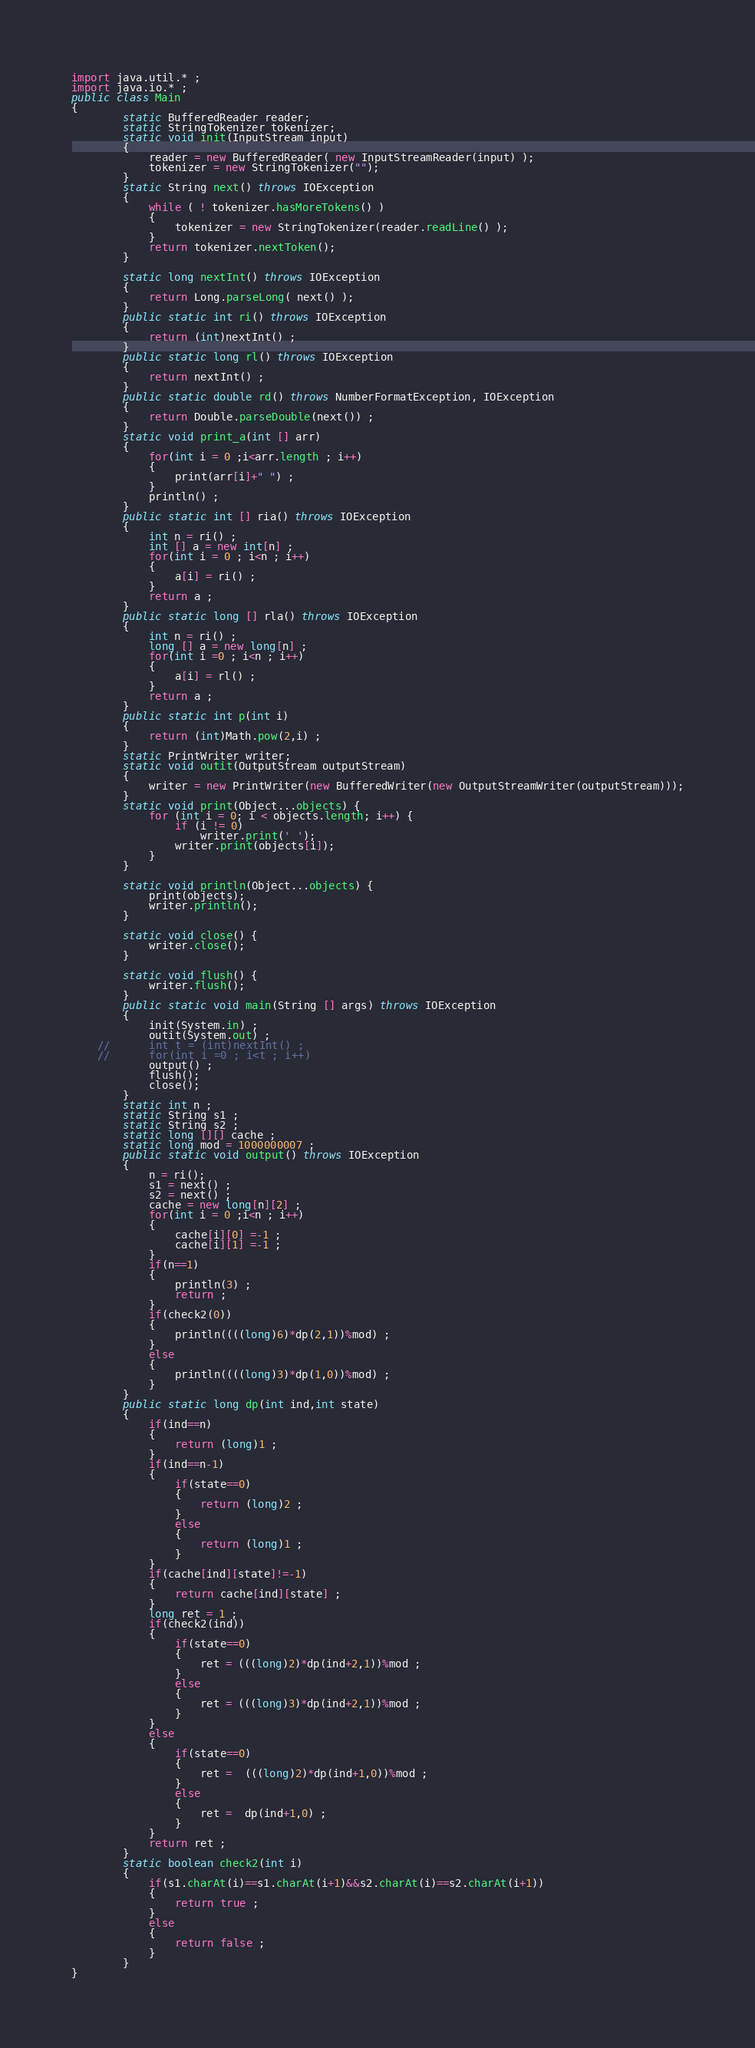<code> <loc_0><loc_0><loc_500><loc_500><_Java_>import java.util.* ;
import java.io.* ;
public class Main
{
		static BufferedReader reader;
        static StringTokenizer tokenizer;
        static void init(InputStream input)
        {
            reader = new BufferedReader( new InputStreamReader(input) );
            tokenizer = new StringTokenizer("");
        }
        static String next() throws IOException
        {
            while ( ! tokenizer.hasMoreTokens() )
            {
                tokenizer = new StringTokenizer(reader.readLine() );
            }
            return tokenizer.nextToken();
        }
     
        static long nextInt() throws IOException
        {
            return Long.parseLong( next() );
        }
        public static int ri() throws IOException
        {
        	return (int)nextInt() ;
        }
        public static long rl() throws IOException
        {
        	return nextInt() ;
        }
        public static double rd() throws NumberFormatException, IOException
        {
        	return Double.parseDouble(next()) ;
        }
        static void print_a(int [] arr)
        {
        	for(int i = 0 ;i<arr.length ; i++)
        	{
        		print(arr[i]+" ") ;
        	}
        	println() ;
        }
        public static int [] ria() throws IOException
        {
        	int n = ri() ;
        	int [] a = new int[n] ;
        	for(int i = 0 ; i<n ; i++)
        	{
        		a[i] = ri() ;
        	}
        	return a ;
        }
        public static long [] rla() throws IOException
        {
        	int n = ri() ;
        	long [] a = new long[n] ;
        	for(int i =0 ; i<n ; i++)
        	{
        		a[i] = rl() ;
        	}
        	return a ;
        }
        public static int p(int i)
        {
        	return (int)Math.pow(2,i) ;
        }
        static PrintWriter writer;
        static void outit(OutputStream outputStream)
        {
            writer = new PrintWriter(new BufferedWriter(new OutputStreamWriter(outputStream)));
        }
        static void print(Object...objects) {
            for (int i = 0; i < objects.length; i++) {
                if (i != 0)
                    writer.print(' ');
                writer.print(objects[i]);
            }
        }
     
        static void println(Object...objects) {
            print(objects);
            writer.println();
        }
     
        static void close() {
            writer.close();
        }
     
        static void flush() {
            writer.flush();
        }
        public static void main(String [] args) throws IOException
        {
            init(System.in) ;
            outit(System.out) ;
    //    	int t = (int)nextInt() ;
    //    	for(int i =0 ; i<t ; i++)
            output() ;
            flush();
            close();
        }
        static int n ;
        static String s1 ;
        static String s2 ;
        static long [][] cache ;
        static long mod = 1000000007 ;
        public static void output() throws IOException
        {
        	n = ri();
        	s1 = next() ;
        	s2 = next() ;
        	cache = new long[n][2] ;
        	for(int i = 0 ;i<n ; i++)
        	{
        		cache[i][0] =-1 ;
        		cache[i][1] =-1 ;
        	}
        	if(n==1)
        	{
        		println(3) ;
        		return ;
        	}
        	if(check2(0))
        	{
        		println((((long)6)*dp(2,1))%mod) ;
        	}
        	else
        	{
        		println((((long)3)*dp(1,0))%mod) ;
        	}
        }
        public static long dp(int ind,int state)
        {
        	if(ind==n)
        	{
        		return (long)1 ;
        	}
        	if(ind==n-1)
        	{
        		if(state==0)
        		{
        			return (long)2 ;
        		}
        		else
        		{
        			return (long)1 ;
        		}
        	}
        	if(cache[ind][state]!=-1)
        	{
        		return cache[ind][state] ;
        	}
        	long ret = 1 ;
        	if(check2(ind))
        	{
        		if(state==0)
        		{
        			ret = (((long)2)*dp(ind+2,1))%mod ;
        		}
        		else
        		{
        			ret = (((long)3)*dp(ind+2,1))%mod ;
        		}
        	}
        	else
        	{
        		if(state==0)
        		{
        			ret =  (((long)2)*dp(ind+1,0))%mod ;
        		}
        		else
        		{
        			ret =  dp(ind+1,0) ;
        		}
        	}
        	return ret ;
        }
        static boolean check2(int i)
        {
        	if(s1.charAt(i)==s1.charAt(i+1)&&s2.charAt(i)==s2.charAt(i+1))
        	{
        		return true ;
        	}
        	else
        	{
        		return false ;
        	}
        }
}

</code> 